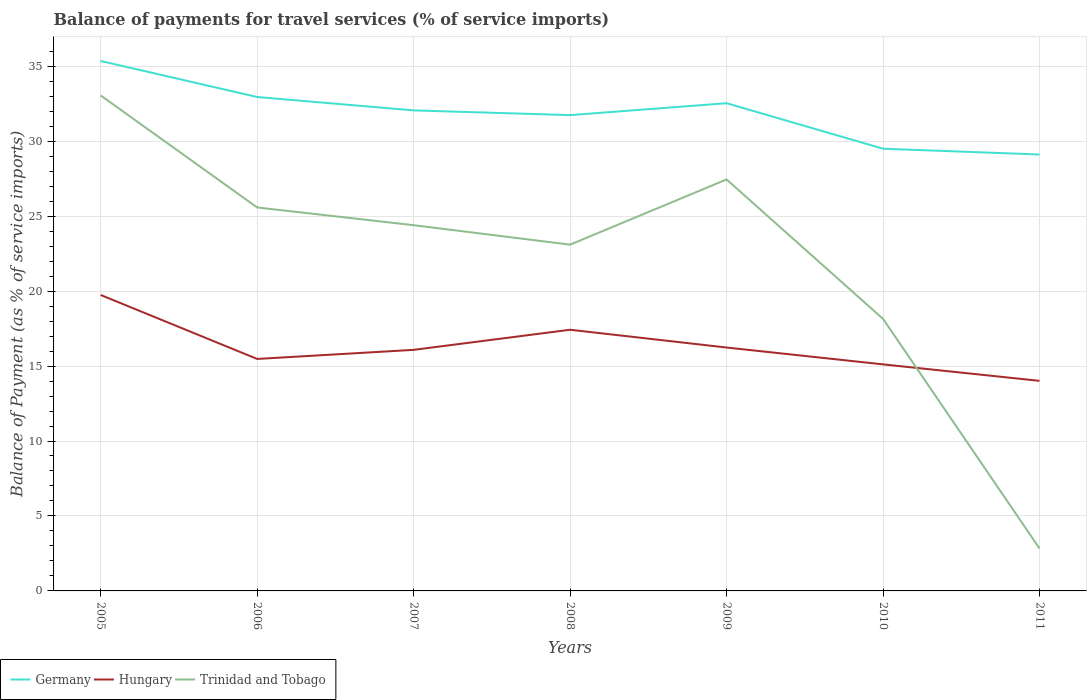Across all years, what is the maximum balance of payments for travel services in Hungary?
Offer a very short reply. 14.01. What is the total balance of payments for travel services in Germany in the graph?
Provide a succinct answer. 5.85. What is the difference between the highest and the second highest balance of payments for travel services in Hungary?
Offer a very short reply. 5.73. What is the difference between the highest and the lowest balance of payments for travel services in Hungary?
Your answer should be very brief. 2. Is the balance of payments for travel services in Germany strictly greater than the balance of payments for travel services in Hungary over the years?
Provide a short and direct response. No. How many lines are there?
Give a very brief answer. 3. What is the difference between two consecutive major ticks on the Y-axis?
Keep it short and to the point. 5. Does the graph contain any zero values?
Give a very brief answer. No. How many legend labels are there?
Your answer should be very brief. 3. What is the title of the graph?
Your response must be concise. Balance of payments for travel services (% of service imports). What is the label or title of the Y-axis?
Keep it short and to the point. Balance of Payment (as % of service imports). What is the Balance of Payment (as % of service imports) in Germany in 2005?
Offer a terse response. 35.35. What is the Balance of Payment (as % of service imports) of Hungary in 2005?
Your answer should be compact. 19.74. What is the Balance of Payment (as % of service imports) in Trinidad and Tobago in 2005?
Offer a terse response. 33.05. What is the Balance of Payment (as % of service imports) of Germany in 2006?
Provide a succinct answer. 32.95. What is the Balance of Payment (as % of service imports) of Hungary in 2006?
Provide a short and direct response. 15.47. What is the Balance of Payment (as % of service imports) in Trinidad and Tobago in 2006?
Make the answer very short. 25.58. What is the Balance of Payment (as % of service imports) of Germany in 2007?
Provide a short and direct response. 32.05. What is the Balance of Payment (as % of service imports) of Hungary in 2007?
Offer a very short reply. 16.08. What is the Balance of Payment (as % of service imports) in Trinidad and Tobago in 2007?
Your answer should be compact. 24.39. What is the Balance of Payment (as % of service imports) in Germany in 2008?
Offer a terse response. 31.74. What is the Balance of Payment (as % of service imports) of Hungary in 2008?
Your answer should be compact. 17.42. What is the Balance of Payment (as % of service imports) of Trinidad and Tobago in 2008?
Your answer should be very brief. 23.1. What is the Balance of Payment (as % of service imports) in Germany in 2009?
Ensure brevity in your answer.  32.53. What is the Balance of Payment (as % of service imports) in Hungary in 2009?
Your response must be concise. 16.24. What is the Balance of Payment (as % of service imports) of Trinidad and Tobago in 2009?
Your answer should be compact. 27.45. What is the Balance of Payment (as % of service imports) in Germany in 2010?
Make the answer very short. 29.5. What is the Balance of Payment (as % of service imports) of Hungary in 2010?
Provide a short and direct response. 15.11. What is the Balance of Payment (as % of service imports) in Trinidad and Tobago in 2010?
Offer a very short reply. 18.14. What is the Balance of Payment (as % of service imports) of Germany in 2011?
Provide a succinct answer. 29.11. What is the Balance of Payment (as % of service imports) of Hungary in 2011?
Offer a terse response. 14.01. What is the Balance of Payment (as % of service imports) in Trinidad and Tobago in 2011?
Your answer should be compact. 2.83. Across all years, what is the maximum Balance of Payment (as % of service imports) of Germany?
Keep it short and to the point. 35.35. Across all years, what is the maximum Balance of Payment (as % of service imports) of Hungary?
Offer a very short reply. 19.74. Across all years, what is the maximum Balance of Payment (as % of service imports) of Trinidad and Tobago?
Your response must be concise. 33.05. Across all years, what is the minimum Balance of Payment (as % of service imports) in Germany?
Make the answer very short. 29.11. Across all years, what is the minimum Balance of Payment (as % of service imports) in Hungary?
Keep it short and to the point. 14.01. Across all years, what is the minimum Balance of Payment (as % of service imports) of Trinidad and Tobago?
Offer a terse response. 2.83. What is the total Balance of Payment (as % of service imports) in Germany in the graph?
Keep it short and to the point. 223.23. What is the total Balance of Payment (as % of service imports) of Hungary in the graph?
Your answer should be very brief. 114.07. What is the total Balance of Payment (as % of service imports) of Trinidad and Tobago in the graph?
Offer a very short reply. 154.54. What is the difference between the Balance of Payment (as % of service imports) of Germany in 2005 and that in 2006?
Your answer should be very brief. 2.41. What is the difference between the Balance of Payment (as % of service imports) in Hungary in 2005 and that in 2006?
Your response must be concise. 4.27. What is the difference between the Balance of Payment (as % of service imports) in Trinidad and Tobago in 2005 and that in 2006?
Your answer should be compact. 7.47. What is the difference between the Balance of Payment (as % of service imports) of Germany in 2005 and that in 2007?
Make the answer very short. 3.3. What is the difference between the Balance of Payment (as % of service imports) of Hungary in 2005 and that in 2007?
Provide a short and direct response. 3.66. What is the difference between the Balance of Payment (as % of service imports) of Trinidad and Tobago in 2005 and that in 2007?
Make the answer very short. 8.66. What is the difference between the Balance of Payment (as % of service imports) in Germany in 2005 and that in 2008?
Offer a terse response. 3.61. What is the difference between the Balance of Payment (as % of service imports) in Hungary in 2005 and that in 2008?
Provide a succinct answer. 2.32. What is the difference between the Balance of Payment (as % of service imports) of Trinidad and Tobago in 2005 and that in 2008?
Your answer should be compact. 9.95. What is the difference between the Balance of Payment (as % of service imports) in Germany in 2005 and that in 2009?
Give a very brief answer. 2.82. What is the difference between the Balance of Payment (as % of service imports) in Hungary in 2005 and that in 2009?
Keep it short and to the point. 3.51. What is the difference between the Balance of Payment (as % of service imports) of Trinidad and Tobago in 2005 and that in 2009?
Your answer should be compact. 5.61. What is the difference between the Balance of Payment (as % of service imports) in Germany in 2005 and that in 2010?
Keep it short and to the point. 5.85. What is the difference between the Balance of Payment (as % of service imports) of Hungary in 2005 and that in 2010?
Make the answer very short. 4.63. What is the difference between the Balance of Payment (as % of service imports) of Trinidad and Tobago in 2005 and that in 2010?
Offer a very short reply. 14.91. What is the difference between the Balance of Payment (as % of service imports) in Germany in 2005 and that in 2011?
Offer a terse response. 6.24. What is the difference between the Balance of Payment (as % of service imports) of Hungary in 2005 and that in 2011?
Provide a succinct answer. 5.73. What is the difference between the Balance of Payment (as % of service imports) of Trinidad and Tobago in 2005 and that in 2011?
Ensure brevity in your answer.  30.22. What is the difference between the Balance of Payment (as % of service imports) in Germany in 2006 and that in 2007?
Provide a short and direct response. 0.89. What is the difference between the Balance of Payment (as % of service imports) of Hungary in 2006 and that in 2007?
Your response must be concise. -0.61. What is the difference between the Balance of Payment (as % of service imports) in Trinidad and Tobago in 2006 and that in 2007?
Make the answer very short. 1.18. What is the difference between the Balance of Payment (as % of service imports) in Germany in 2006 and that in 2008?
Your response must be concise. 1.21. What is the difference between the Balance of Payment (as % of service imports) in Hungary in 2006 and that in 2008?
Ensure brevity in your answer.  -1.95. What is the difference between the Balance of Payment (as % of service imports) in Trinidad and Tobago in 2006 and that in 2008?
Provide a short and direct response. 2.48. What is the difference between the Balance of Payment (as % of service imports) in Germany in 2006 and that in 2009?
Your answer should be compact. 0.41. What is the difference between the Balance of Payment (as % of service imports) of Hungary in 2006 and that in 2009?
Make the answer very short. -0.76. What is the difference between the Balance of Payment (as % of service imports) in Trinidad and Tobago in 2006 and that in 2009?
Your answer should be very brief. -1.87. What is the difference between the Balance of Payment (as % of service imports) of Germany in 2006 and that in 2010?
Keep it short and to the point. 3.45. What is the difference between the Balance of Payment (as % of service imports) of Hungary in 2006 and that in 2010?
Give a very brief answer. 0.36. What is the difference between the Balance of Payment (as % of service imports) in Trinidad and Tobago in 2006 and that in 2010?
Provide a succinct answer. 7.43. What is the difference between the Balance of Payment (as % of service imports) in Germany in 2006 and that in 2011?
Provide a succinct answer. 3.84. What is the difference between the Balance of Payment (as % of service imports) in Hungary in 2006 and that in 2011?
Provide a succinct answer. 1.46. What is the difference between the Balance of Payment (as % of service imports) in Trinidad and Tobago in 2006 and that in 2011?
Provide a short and direct response. 22.75. What is the difference between the Balance of Payment (as % of service imports) in Germany in 2007 and that in 2008?
Offer a very short reply. 0.32. What is the difference between the Balance of Payment (as % of service imports) in Hungary in 2007 and that in 2008?
Offer a very short reply. -1.34. What is the difference between the Balance of Payment (as % of service imports) of Trinidad and Tobago in 2007 and that in 2008?
Offer a terse response. 1.3. What is the difference between the Balance of Payment (as % of service imports) of Germany in 2007 and that in 2009?
Give a very brief answer. -0.48. What is the difference between the Balance of Payment (as % of service imports) of Hungary in 2007 and that in 2009?
Provide a short and direct response. -0.16. What is the difference between the Balance of Payment (as % of service imports) in Trinidad and Tobago in 2007 and that in 2009?
Keep it short and to the point. -3.05. What is the difference between the Balance of Payment (as % of service imports) in Germany in 2007 and that in 2010?
Make the answer very short. 2.56. What is the difference between the Balance of Payment (as % of service imports) in Hungary in 2007 and that in 2010?
Offer a very short reply. 0.97. What is the difference between the Balance of Payment (as % of service imports) in Trinidad and Tobago in 2007 and that in 2010?
Provide a short and direct response. 6.25. What is the difference between the Balance of Payment (as % of service imports) of Germany in 2007 and that in 2011?
Offer a terse response. 2.94. What is the difference between the Balance of Payment (as % of service imports) in Hungary in 2007 and that in 2011?
Offer a terse response. 2.07. What is the difference between the Balance of Payment (as % of service imports) of Trinidad and Tobago in 2007 and that in 2011?
Your response must be concise. 21.56. What is the difference between the Balance of Payment (as % of service imports) in Germany in 2008 and that in 2009?
Ensure brevity in your answer.  -0.79. What is the difference between the Balance of Payment (as % of service imports) of Hungary in 2008 and that in 2009?
Provide a succinct answer. 1.19. What is the difference between the Balance of Payment (as % of service imports) in Trinidad and Tobago in 2008 and that in 2009?
Provide a succinct answer. -4.35. What is the difference between the Balance of Payment (as % of service imports) in Germany in 2008 and that in 2010?
Offer a terse response. 2.24. What is the difference between the Balance of Payment (as % of service imports) of Hungary in 2008 and that in 2010?
Make the answer very short. 2.31. What is the difference between the Balance of Payment (as % of service imports) of Trinidad and Tobago in 2008 and that in 2010?
Provide a succinct answer. 4.95. What is the difference between the Balance of Payment (as % of service imports) of Germany in 2008 and that in 2011?
Your response must be concise. 2.63. What is the difference between the Balance of Payment (as % of service imports) of Hungary in 2008 and that in 2011?
Provide a succinct answer. 3.41. What is the difference between the Balance of Payment (as % of service imports) in Trinidad and Tobago in 2008 and that in 2011?
Make the answer very short. 20.27. What is the difference between the Balance of Payment (as % of service imports) of Germany in 2009 and that in 2010?
Provide a short and direct response. 3.03. What is the difference between the Balance of Payment (as % of service imports) of Hungary in 2009 and that in 2010?
Provide a succinct answer. 1.12. What is the difference between the Balance of Payment (as % of service imports) of Trinidad and Tobago in 2009 and that in 2010?
Offer a terse response. 9.3. What is the difference between the Balance of Payment (as % of service imports) of Germany in 2009 and that in 2011?
Offer a very short reply. 3.42. What is the difference between the Balance of Payment (as % of service imports) of Hungary in 2009 and that in 2011?
Make the answer very short. 2.22. What is the difference between the Balance of Payment (as % of service imports) in Trinidad and Tobago in 2009 and that in 2011?
Your answer should be compact. 24.62. What is the difference between the Balance of Payment (as % of service imports) of Germany in 2010 and that in 2011?
Give a very brief answer. 0.39. What is the difference between the Balance of Payment (as % of service imports) of Hungary in 2010 and that in 2011?
Provide a short and direct response. 1.1. What is the difference between the Balance of Payment (as % of service imports) of Trinidad and Tobago in 2010 and that in 2011?
Your response must be concise. 15.31. What is the difference between the Balance of Payment (as % of service imports) in Germany in 2005 and the Balance of Payment (as % of service imports) in Hungary in 2006?
Your response must be concise. 19.88. What is the difference between the Balance of Payment (as % of service imports) in Germany in 2005 and the Balance of Payment (as % of service imports) in Trinidad and Tobago in 2006?
Offer a very short reply. 9.77. What is the difference between the Balance of Payment (as % of service imports) of Hungary in 2005 and the Balance of Payment (as % of service imports) of Trinidad and Tobago in 2006?
Ensure brevity in your answer.  -5.84. What is the difference between the Balance of Payment (as % of service imports) of Germany in 2005 and the Balance of Payment (as % of service imports) of Hungary in 2007?
Your response must be concise. 19.27. What is the difference between the Balance of Payment (as % of service imports) of Germany in 2005 and the Balance of Payment (as % of service imports) of Trinidad and Tobago in 2007?
Give a very brief answer. 10.96. What is the difference between the Balance of Payment (as % of service imports) in Hungary in 2005 and the Balance of Payment (as % of service imports) in Trinidad and Tobago in 2007?
Ensure brevity in your answer.  -4.65. What is the difference between the Balance of Payment (as % of service imports) in Germany in 2005 and the Balance of Payment (as % of service imports) in Hungary in 2008?
Provide a succinct answer. 17.93. What is the difference between the Balance of Payment (as % of service imports) of Germany in 2005 and the Balance of Payment (as % of service imports) of Trinidad and Tobago in 2008?
Your answer should be very brief. 12.25. What is the difference between the Balance of Payment (as % of service imports) of Hungary in 2005 and the Balance of Payment (as % of service imports) of Trinidad and Tobago in 2008?
Provide a short and direct response. -3.36. What is the difference between the Balance of Payment (as % of service imports) in Germany in 2005 and the Balance of Payment (as % of service imports) in Hungary in 2009?
Provide a short and direct response. 19.12. What is the difference between the Balance of Payment (as % of service imports) in Germany in 2005 and the Balance of Payment (as % of service imports) in Trinidad and Tobago in 2009?
Ensure brevity in your answer.  7.9. What is the difference between the Balance of Payment (as % of service imports) in Hungary in 2005 and the Balance of Payment (as % of service imports) in Trinidad and Tobago in 2009?
Your response must be concise. -7.7. What is the difference between the Balance of Payment (as % of service imports) of Germany in 2005 and the Balance of Payment (as % of service imports) of Hungary in 2010?
Offer a very short reply. 20.24. What is the difference between the Balance of Payment (as % of service imports) in Germany in 2005 and the Balance of Payment (as % of service imports) in Trinidad and Tobago in 2010?
Provide a short and direct response. 17.21. What is the difference between the Balance of Payment (as % of service imports) of Hungary in 2005 and the Balance of Payment (as % of service imports) of Trinidad and Tobago in 2010?
Your answer should be compact. 1.6. What is the difference between the Balance of Payment (as % of service imports) of Germany in 2005 and the Balance of Payment (as % of service imports) of Hungary in 2011?
Offer a terse response. 21.34. What is the difference between the Balance of Payment (as % of service imports) of Germany in 2005 and the Balance of Payment (as % of service imports) of Trinidad and Tobago in 2011?
Provide a succinct answer. 32.52. What is the difference between the Balance of Payment (as % of service imports) in Hungary in 2005 and the Balance of Payment (as % of service imports) in Trinidad and Tobago in 2011?
Ensure brevity in your answer.  16.91. What is the difference between the Balance of Payment (as % of service imports) of Germany in 2006 and the Balance of Payment (as % of service imports) of Hungary in 2007?
Offer a very short reply. 16.87. What is the difference between the Balance of Payment (as % of service imports) in Germany in 2006 and the Balance of Payment (as % of service imports) in Trinidad and Tobago in 2007?
Your answer should be compact. 8.55. What is the difference between the Balance of Payment (as % of service imports) of Hungary in 2006 and the Balance of Payment (as % of service imports) of Trinidad and Tobago in 2007?
Your answer should be very brief. -8.92. What is the difference between the Balance of Payment (as % of service imports) in Germany in 2006 and the Balance of Payment (as % of service imports) in Hungary in 2008?
Make the answer very short. 15.53. What is the difference between the Balance of Payment (as % of service imports) of Germany in 2006 and the Balance of Payment (as % of service imports) of Trinidad and Tobago in 2008?
Offer a very short reply. 9.85. What is the difference between the Balance of Payment (as % of service imports) of Hungary in 2006 and the Balance of Payment (as % of service imports) of Trinidad and Tobago in 2008?
Offer a terse response. -7.62. What is the difference between the Balance of Payment (as % of service imports) in Germany in 2006 and the Balance of Payment (as % of service imports) in Hungary in 2009?
Your answer should be very brief. 16.71. What is the difference between the Balance of Payment (as % of service imports) of Germany in 2006 and the Balance of Payment (as % of service imports) of Trinidad and Tobago in 2009?
Keep it short and to the point. 5.5. What is the difference between the Balance of Payment (as % of service imports) of Hungary in 2006 and the Balance of Payment (as % of service imports) of Trinidad and Tobago in 2009?
Your response must be concise. -11.97. What is the difference between the Balance of Payment (as % of service imports) of Germany in 2006 and the Balance of Payment (as % of service imports) of Hungary in 2010?
Ensure brevity in your answer.  17.83. What is the difference between the Balance of Payment (as % of service imports) of Germany in 2006 and the Balance of Payment (as % of service imports) of Trinidad and Tobago in 2010?
Offer a very short reply. 14.8. What is the difference between the Balance of Payment (as % of service imports) in Hungary in 2006 and the Balance of Payment (as % of service imports) in Trinidad and Tobago in 2010?
Ensure brevity in your answer.  -2.67. What is the difference between the Balance of Payment (as % of service imports) in Germany in 2006 and the Balance of Payment (as % of service imports) in Hungary in 2011?
Make the answer very short. 18.93. What is the difference between the Balance of Payment (as % of service imports) in Germany in 2006 and the Balance of Payment (as % of service imports) in Trinidad and Tobago in 2011?
Your response must be concise. 30.12. What is the difference between the Balance of Payment (as % of service imports) of Hungary in 2006 and the Balance of Payment (as % of service imports) of Trinidad and Tobago in 2011?
Your answer should be compact. 12.64. What is the difference between the Balance of Payment (as % of service imports) of Germany in 2007 and the Balance of Payment (as % of service imports) of Hungary in 2008?
Your answer should be compact. 14.63. What is the difference between the Balance of Payment (as % of service imports) in Germany in 2007 and the Balance of Payment (as % of service imports) in Trinidad and Tobago in 2008?
Ensure brevity in your answer.  8.95. What is the difference between the Balance of Payment (as % of service imports) of Hungary in 2007 and the Balance of Payment (as % of service imports) of Trinidad and Tobago in 2008?
Make the answer very short. -7.02. What is the difference between the Balance of Payment (as % of service imports) in Germany in 2007 and the Balance of Payment (as % of service imports) in Hungary in 2009?
Ensure brevity in your answer.  15.82. What is the difference between the Balance of Payment (as % of service imports) of Germany in 2007 and the Balance of Payment (as % of service imports) of Trinidad and Tobago in 2009?
Your answer should be compact. 4.61. What is the difference between the Balance of Payment (as % of service imports) in Hungary in 2007 and the Balance of Payment (as % of service imports) in Trinidad and Tobago in 2009?
Provide a succinct answer. -11.37. What is the difference between the Balance of Payment (as % of service imports) in Germany in 2007 and the Balance of Payment (as % of service imports) in Hungary in 2010?
Your answer should be compact. 16.94. What is the difference between the Balance of Payment (as % of service imports) in Germany in 2007 and the Balance of Payment (as % of service imports) in Trinidad and Tobago in 2010?
Provide a short and direct response. 13.91. What is the difference between the Balance of Payment (as % of service imports) in Hungary in 2007 and the Balance of Payment (as % of service imports) in Trinidad and Tobago in 2010?
Provide a succinct answer. -2.06. What is the difference between the Balance of Payment (as % of service imports) in Germany in 2007 and the Balance of Payment (as % of service imports) in Hungary in 2011?
Offer a very short reply. 18.04. What is the difference between the Balance of Payment (as % of service imports) of Germany in 2007 and the Balance of Payment (as % of service imports) of Trinidad and Tobago in 2011?
Give a very brief answer. 29.22. What is the difference between the Balance of Payment (as % of service imports) in Hungary in 2007 and the Balance of Payment (as % of service imports) in Trinidad and Tobago in 2011?
Ensure brevity in your answer.  13.25. What is the difference between the Balance of Payment (as % of service imports) in Germany in 2008 and the Balance of Payment (as % of service imports) in Hungary in 2009?
Your response must be concise. 15.5. What is the difference between the Balance of Payment (as % of service imports) of Germany in 2008 and the Balance of Payment (as % of service imports) of Trinidad and Tobago in 2009?
Give a very brief answer. 4.29. What is the difference between the Balance of Payment (as % of service imports) in Hungary in 2008 and the Balance of Payment (as % of service imports) in Trinidad and Tobago in 2009?
Keep it short and to the point. -10.03. What is the difference between the Balance of Payment (as % of service imports) of Germany in 2008 and the Balance of Payment (as % of service imports) of Hungary in 2010?
Your answer should be compact. 16.63. What is the difference between the Balance of Payment (as % of service imports) of Germany in 2008 and the Balance of Payment (as % of service imports) of Trinidad and Tobago in 2010?
Provide a short and direct response. 13.59. What is the difference between the Balance of Payment (as % of service imports) in Hungary in 2008 and the Balance of Payment (as % of service imports) in Trinidad and Tobago in 2010?
Provide a short and direct response. -0.72. What is the difference between the Balance of Payment (as % of service imports) in Germany in 2008 and the Balance of Payment (as % of service imports) in Hungary in 2011?
Your answer should be very brief. 17.73. What is the difference between the Balance of Payment (as % of service imports) of Germany in 2008 and the Balance of Payment (as % of service imports) of Trinidad and Tobago in 2011?
Your answer should be compact. 28.91. What is the difference between the Balance of Payment (as % of service imports) of Hungary in 2008 and the Balance of Payment (as % of service imports) of Trinidad and Tobago in 2011?
Offer a very short reply. 14.59. What is the difference between the Balance of Payment (as % of service imports) of Germany in 2009 and the Balance of Payment (as % of service imports) of Hungary in 2010?
Provide a short and direct response. 17.42. What is the difference between the Balance of Payment (as % of service imports) of Germany in 2009 and the Balance of Payment (as % of service imports) of Trinidad and Tobago in 2010?
Make the answer very short. 14.39. What is the difference between the Balance of Payment (as % of service imports) in Hungary in 2009 and the Balance of Payment (as % of service imports) in Trinidad and Tobago in 2010?
Keep it short and to the point. -1.91. What is the difference between the Balance of Payment (as % of service imports) of Germany in 2009 and the Balance of Payment (as % of service imports) of Hungary in 2011?
Offer a terse response. 18.52. What is the difference between the Balance of Payment (as % of service imports) in Germany in 2009 and the Balance of Payment (as % of service imports) in Trinidad and Tobago in 2011?
Keep it short and to the point. 29.7. What is the difference between the Balance of Payment (as % of service imports) in Hungary in 2009 and the Balance of Payment (as % of service imports) in Trinidad and Tobago in 2011?
Your answer should be very brief. 13.41. What is the difference between the Balance of Payment (as % of service imports) in Germany in 2010 and the Balance of Payment (as % of service imports) in Hungary in 2011?
Offer a very short reply. 15.49. What is the difference between the Balance of Payment (as % of service imports) of Germany in 2010 and the Balance of Payment (as % of service imports) of Trinidad and Tobago in 2011?
Keep it short and to the point. 26.67. What is the difference between the Balance of Payment (as % of service imports) in Hungary in 2010 and the Balance of Payment (as % of service imports) in Trinidad and Tobago in 2011?
Make the answer very short. 12.28. What is the average Balance of Payment (as % of service imports) in Germany per year?
Your response must be concise. 31.89. What is the average Balance of Payment (as % of service imports) in Hungary per year?
Your answer should be compact. 16.3. What is the average Balance of Payment (as % of service imports) in Trinidad and Tobago per year?
Keep it short and to the point. 22.08. In the year 2005, what is the difference between the Balance of Payment (as % of service imports) of Germany and Balance of Payment (as % of service imports) of Hungary?
Offer a terse response. 15.61. In the year 2005, what is the difference between the Balance of Payment (as % of service imports) of Germany and Balance of Payment (as % of service imports) of Trinidad and Tobago?
Provide a short and direct response. 2.3. In the year 2005, what is the difference between the Balance of Payment (as % of service imports) in Hungary and Balance of Payment (as % of service imports) in Trinidad and Tobago?
Your answer should be compact. -13.31. In the year 2006, what is the difference between the Balance of Payment (as % of service imports) of Germany and Balance of Payment (as % of service imports) of Hungary?
Make the answer very short. 17.47. In the year 2006, what is the difference between the Balance of Payment (as % of service imports) of Germany and Balance of Payment (as % of service imports) of Trinidad and Tobago?
Offer a terse response. 7.37. In the year 2006, what is the difference between the Balance of Payment (as % of service imports) in Hungary and Balance of Payment (as % of service imports) in Trinidad and Tobago?
Your answer should be compact. -10.1. In the year 2007, what is the difference between the Balance of Payment (as % of service imports) of Germany and Balance of Payment (as % of service imports) of Hungary?
Your answer should be compact. 15.97. In the year 2007, what is the difference between the Balance of Payment (as % of service imports) in Germany and Balance of Payment (as % of service imports) in Trinidad and Tobago?
Your answer should be very brief. 7.66. In the year 2007, what is the difference between the Balance of Payment (as % of service imports) of Hungary and Balance of Payment (as % of service imports) of Trinidad and Tobago?
Provide a succinct answer. -8.31. In the year 2008, what is the difference between the Balance of Payment (as % of service imports) in Germany and Balance of Payment (as % of service imports) in Hungary?
Make the answer very short. 14.32. In the year 2008, what is the difference between the Balance of Payment (as % of service imports) in Germany and Balance of Payment (as % of service imports) in Trinidad and Tobago?
Provide a short and direct response. 8.64. In the year 2008, what is the difference between the Balance of Payment (as % of service imports) in Hungary and Balance of Payment (as % of service imports) in Trinidad and Tobago?
Your answer should be compact. -5.68. In the year 2009, what is the difference between the Balance of Payment (as % of service imports) in Germany and Balance of Payment (as % of service imports) in Hungary?
Offer a very short reply. 16.3. In the year 2009, what is the difference between the Balance of Payment (as % of service imports) in Germany and Balance of Payment (as % of service imports) in Trinidad and Tobago?
Make the answer very short. 5.09. In the year 2009, what is the difference between the Balance of Payment (as % of service imports) of Hungary and Balance of Payment (as % of service imports) of Trinidad and Tobago?
Your response must be concise. -11.21. In the year 2010, what is the difference between the Balance of Payment (as % of service imports) in Germany and Balance of Payment (as % of service imports) in Hungary?
Your response must be concise. 14.39. In the year 2010, what is the difference between the Balance of Payment (as % of service imports) of Germany and Balance of Payment (as % of service imports) of Trinidad and Tobago?
Provide a short and direct response. 11.35. In the year 2010, what is the difference between the Balance of Payment (as % of service imports) of Hungary and Balance of Payment (as % of service imports) of Trinidad and Tobago?
Offer a very short reply. -3.03. In the year 2011, what is the difference between the Balance of Payment (as % of service imports) of Germany and Balance of Payment (as % of service imports) of Hungary?
Give a very brief answer. 15.1. In the year 2011, what is the difference between the Balance of Payment (as % of service imports) of Germany and Balance of Payment (as % of service imports) of Trinidad and Tobago?
Make the answer very short. 26.28. In the year 2011, what is the difference between the Balance of Payment (as % of service imports) of Hungary and Balance of Payment (as % of service imports) of Trinidad and Tobago?
Give a very brief answer. 11.18. What is the ratio of the Balance of Payment (as % of service imports) in Germany in 2005 to that in 2006?
Your answer should be very brief. 1.07. What is the ratio of the Balance of Payment (as % of service imports) in Hungary in 2005 to that in 2006?
Ensure brevity in your answer.  1.28. What is the ratio of the Balance of Payment (as % of service imports) in Trinidad and Tobago in 2005 to that in 2006?
Provide a succinct answer. 1.29. What is the ratio of the Balance of Payment (as % of service imports) in Germany in 2005 to that in 2007?
Provide a succinct answer. 1.1. What is the ratio of the Balance of Payment (as % of service imports) in Hungary in 2005 to that in 2007?
Provide a succinct answer. 1.23. What is the ratio of the Balance of Payment (as % of service imports) in Trinidad and Tobago in 2005 to that in 2007?
Give a very brief answer. 1.35. What is the ratio of the Balance of Payment (as % of service imports) in Germany in 2005 to that in 2008?
Offer a terse response. 1.11. What is the ratio of the Balance of Payment (as % of service imports) in Hungary in 2005 to that in 2008?
Offer a very short reply. 1.13. What is the ratio of the Balance of Payment (as % of service imports) of Trinidad and Tobago in 2005 to that in 2008?
Your answer should be compact. 1.43. What is the ratio of the Balance of Payment (as % of service imports) in Germany in 2005 to that in 2009?
Provide a succinct answer. 1.09. What is the ratio of the Balance of Payment (as % of service imports) of Hungary in 2005 to that in 2009?
Provide a short and direct response. 1.22. What is the ratio of the Balance of Payment (as % of service imports) of Trinidad and Tobago in 2005 to that in 2009?
Offer a terse response. 1.2. What is the ratio of the Balance of Payment (as % of service imports) of Germany in 2005 to that in 2010?
Your response must be concise. 1.2. What is the ratio of the Balance of Payment (as % of service imports) in Hungary in 2005 to that in 2010?
Your response must be concise. 1.31. What is the ratio of the Balance of Payment (as % of service imports) of Trinidad and Tobago in 2005 to that in 2010?
Your answer should be very brief. 1.82. What is the ratio of the Balance of Payment (as % of service imports) in Germany in 2005 to that in 2011?
Your answer should be compact. 1.21. What is the ratio of the Balance of Payment (as % of service imports) in Hungary in 2005 to that in 2011?
Provide a succinct answer. 1.41. What is the ratio of the Balance of Payment (as % of service imports) in Trinidad and Tobago in 2005 to that in 2011?
Keep it short and to the point. 11.68. What is the ratio of the Balance of Payment (as % of service imports) of Germany in 2006 to that in 2007?
Provide a succinct answer. 1.03. What is the ratio of the Balance of Payment (as % of service imports) in Hungary in 2006 to that in 2007?
Offer a very short reply. 0.96. What is the ratio of the Balance of Payment (as % of service imports) in Trinidad and Tobago in 2006 to that in 2007?
Provide a short and direct response. 1.05. What is the ratio of the Balance of Payment (as % of service imports) in Germany in 2006 to that in 2008?
Give a very brief answer. 1.04. What is the ratio of the Balance of Payment (as % of service imports) of Hungary in 2006 to that in 2008?
Offer a terse response. 0.89. What is the ratio of the Balance of Payment (as % of service imports) in Trinidad and Tobago in 2006 to that in 2008?
Your answer should be compact. 1.11. What is the ratio of the Balance of Payment (as % of service imports) of Germany in 2006 to that in 2009?
Give a very brief answer. 1.01. What is the ratio of the Balance of Payment (as % of service imports) of Hungary in 2006 to that in 2009?
Your answer should be very brief. 0.95. What is the ratio of the Balance of Payment (as % of service imports) of Trinidad and Tobago in 2006 to that in 2009?
Make the answer very short. 0.93. What is the ratio of the Balance of Payment (as % of service imports) in Germany in 2006 to that in 2010?
Provide a short and direct response. 1.12. What is the ratio of the Balance of Payment (as % of service imports) of Hungary in 2006 to that in 2010?
Provide a succinct answer. 1.02. What is the ratio of the Balance of Payment (as % of service imports) of Trinidad and Tobago in 2006 to that in 2010?
Your answer should be very brief. 1.41. What is the ratio of the Balance of Payment (as % of service imports) in Germany in 2006 to that in 2011?
Keep it short and to the point. 1.13. What is the ratio of the Balance of Payment (as % of service imports) in Hungary in 2006 to that in 2011?
Your response must be concise. 1.1. What is the ratio of the Balance of Payment (as % of service imports) of Trinidad and Tobago in 2006 to that in 2011?
Your response must be concise. 9.04. What is the ratio of the Balance of Payment (as % of service imports) of Germany in 2007 to that in 2008?
Make the answer very short. 1.01. What is the ratio of the Balance of Payment (as % of service imports) of Trinidad and Tobago in 2007 to that in 2008?
Give a very brief answer. 1.06. What is the ratio of the Balance of Payment (as % of service imports) in Hungary in 2007 to that in 2009?
Your answer should be very brief. 0.99. What is the ratio of the Balance of Payment (as % of service imports) in Trinidad and Tobago in 2007 to that in 2009?
Provide a succinct answer. 0.89. What is the ratio of the Balance of Payment (as % of service imports) in Germany in 2007 to that in 2010?
Offer a terse response. 1.09. What is the ratio of the Balance of Payment (as % of service imports) in Hungary in 2007 to that in 2010?
Ensure brevity in your answer.  1.06. What is the ratio of the Balance of Payment (as % of service imports) of Trinidad and Tobago in 2007 to that in 2010?
Give a very brief answer. 1.34. What is the ratio of the Balance of Payment (as % of service imports) of Germany in 2007 to that in 2011?
Your response must be concise. 1.1. What is the ratio of the Balance of Payment (as % of service imports) of Hungary in 2007 to that in 2011?
Make the answer very short. 1.15. What is the ratio of the Balance of Payment (as % of service imports) in Trinidad and Tobago in 2007 to that in 2011?
Ensure brevity in your answer.  8.62. What is the ratio of the Balance of Payment (as % of service imports) in Germany in 2008 to that in 2009?
Your answer should be compact. 0.98. What is the ratio of the Balance of Payment (as % of service imports) in Hungary in 2008 to that in 2009?
Your answer should be very brief. 1.07. What is the ratio of the Balance of Payment (as % of service imports) in Trinidad and Tobago in 2008 to that in 2009?
Offer a terse response. 0.84. What is the ratio of the Balance of Payment (as % of service imports) in Germany in 2008 to that in 2010?
Provide a succinct answer. 1.08. What is the ratio of the Balance of Payment (as % of service imports) of Hungary in 2008 to that in 2010?
Offer a very short reply. 1.15. What is the ratio of the Balance of Payment (as % of service imports) in Trinidad and Tobago in 2008 to that in 2010?
Ensure brevity in your answer.  1.27. What is the ratio of the Balance of Payment (as % of service imports) of Germany in 2008 to that in 2011?
Your answer should be compact. 1.09. What is the ratio of the Balance of Payment (as % of service imports) of Hungary in 2008 to that in 2011?
Your response must be concise. 1.24. What is the ratio of the Balance of Payment (as % of service imports) of Trinidad and Tobago in 2008 to that in 2011?
Provide a succinct answer. 8.16. What is the ratio of the Balance of Payment (as % of service imports) of Germany in 2009 to that in 2010?
Provide a succinct answer. 1.1. What is the ratio of the Balance of Payment (as % of service imports) in Hungary in 2009 to that in 2010?
Give a very brief answer. 1.07. What is the ratio of the Balance of Payment (as % of service imports) in Trinidad and Tobago in 2009 to that in 2010?
Offer a terse response. 1.51. What is the ratio of the Balance of Payment (as % of service imports) of Germany in 2009 to that in 2011?
Offer a very short reply. 1.12. What is the ratio of the Balance of Payment (as % of service imports) of Hungary in 2009 to that in 2011?
Your response must be concise. 1.16. What is the ratio of the Balance of Payment (as % of service imports) in Trinidad and Tobago in 2009 to that in 2011?
Provide a succinct answer. 9.7. What is the ratio of the Balance of Payment (as % of service imports) in Germany in 2010 to that in 2011?
Provide a short and direct response. 1.01. What is the ratio of the Balance of Payment (as % of service imports) in Hungary in 2010 to that in 2011?
Ensure brevity in your answer.  1.08. What is the ratio of the Balance of Payment (as % of service imports) in Trinidad and Tobago in 2010 to that in 2011?
Keep it short and to the point. 6.41. What is the difference between the highest and the second highest Balance of Payment (as % of service imports) of Germany?
Keep it short and to the point. 2.41. What is the difference between the highest and the second highest Balance of Payment (as % of service imports) in Hungary?
Offer a terse response. 2.32. What is the difference between the highest and the second highest Balance of Payment (as % of service imports) in Trinidad and Tobago?
Keep it short and to the point. 5.61. What is the difference between the highest and the lowest Balance of Payment (as % of service imports) in Germany?
Provide a succinct answer. 6.24. What is the difference between the highest and the lowest Balance of Payment (as % of service imports) of Hungary?
Your answer should be very brief. 5.73. What is the difference between the highest and the lowest Balance of Payment (as % of service imports) in Trinidad and Tobago?
Keep it short and to the point. 30.22. 